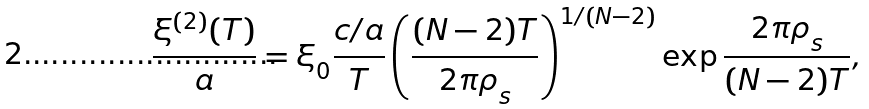<formula> <loc_0><loc_0><loc_500><loc_500>\frac { \xi ^ { ( 2 ) } ( T ) } { a } = \xi ^ { \ } _ { 0 } \frac { c / a } { T } \left ( \frac { ( N - 2 ) T } { 2 \pi \rho ^ { \ } _ { s } } \right ) ^ { 1 / ( N - 2 ) } \exp { \frac { 2 \pi \rho ^ { \ } _ { s } } { ( N - 2 ) T } } ,</formula> 